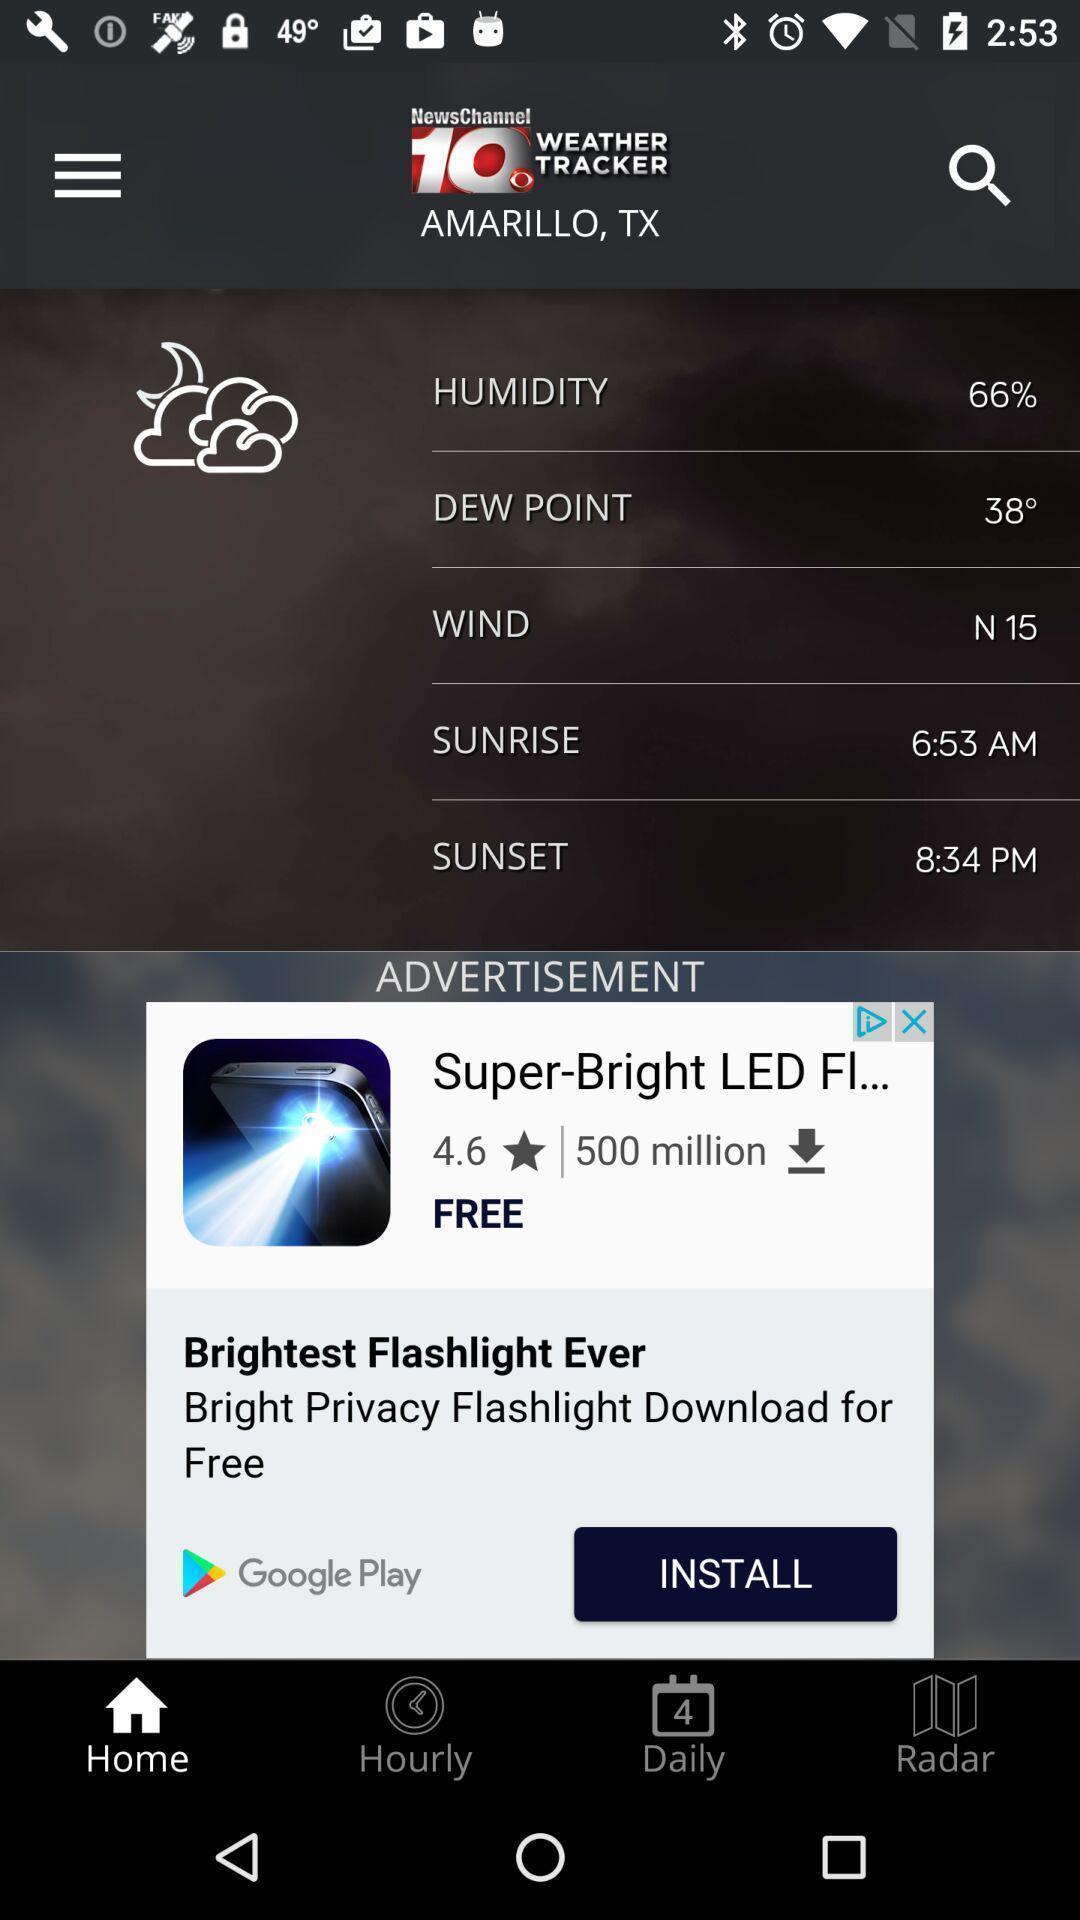Explain what's happening in this screen capture. Page displaying various details of a region in weather application. 